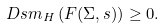Convert formula to latex. <formula><loc_0><loc_0><loc_500><loc_500>\ D { s } m _ { H } \left ( F ( \Sigma , s ) \right ) \geq 0 .</formula> 